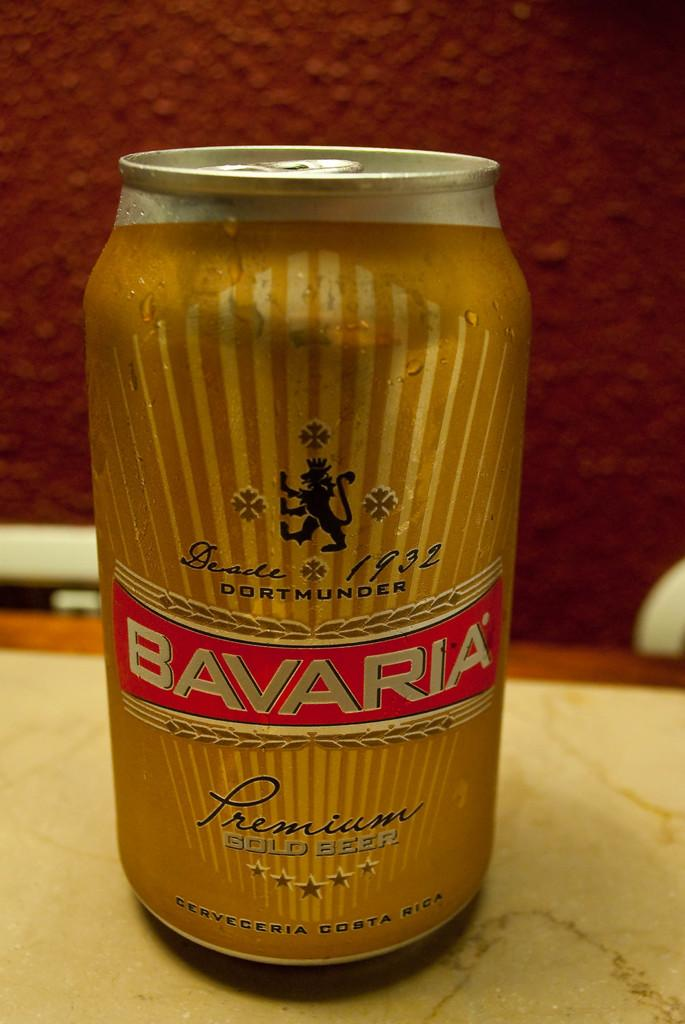<image>
Give a short and clear explanation of the subsequent image. a can that says bavaria on  the front 